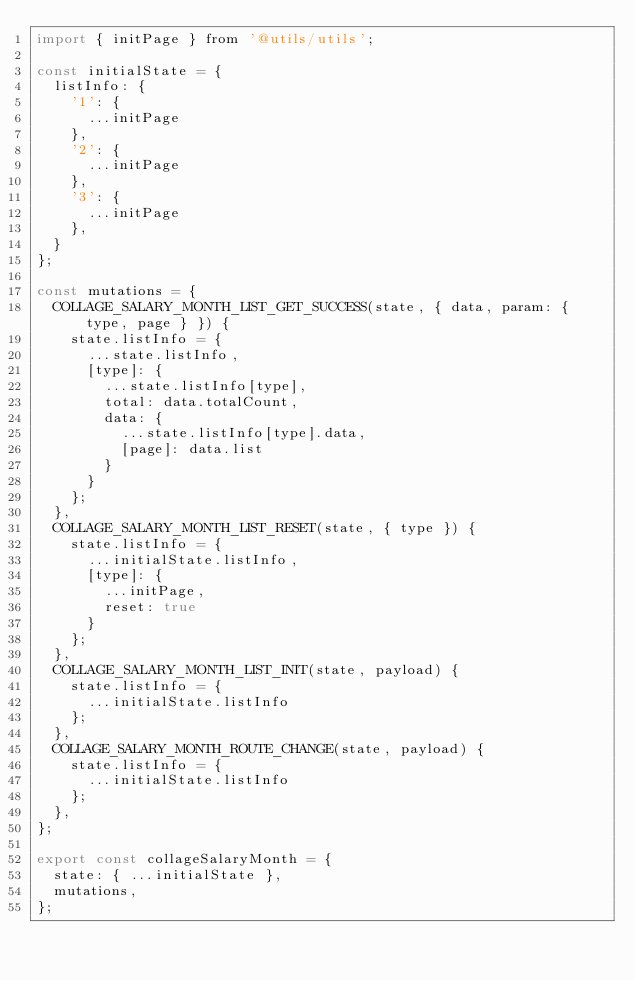<code> <loc_0><loc_0><loc_500><loc_500><_JavaScript_>import { initPage } from '@utils/utils';

const initialState = {
	listInfo: {
		'1': {
			...initPage
		},
		'2': {
			...initPage
		},
		'3': {
			...initPage
		},
	}
};

const mutations = {
	COLLAGE_SALARY_MONTH_LIST_GET_SUCCESS(state, { data, param: { type, page } }) {
		state.listInfo = {
			...state.listInfo,
			[type]: {
				...state.listInfo[type],
				total: data.totalCount,
				data: {
					...state.listInfo[type].data,
					[page]: data.list
				}
			}
		};
	},
	COLLAGE_SALARY_MONTH_LIST_RESET(state, { type }) {
		state.listInfo = {
			...initialState.listInfo,
			[type]: {
				...initPage,
				reset: true
			}
		};
	},
	COLLAGE_SALARY_MONTH_LIST_INIT(state, payload) {
		state.listInfo = {
			...initialState.listInfo
		};
	},
	COLLAGE_SALARY_MONTH_ROUTE_CHANGE(state, payload) {
		state.listInfo = {
			...initialState.listInfo
		};
	},
};

export const collageSalaryMonth = {
	state: { ...initialState },
	mutations,
};
</code> 